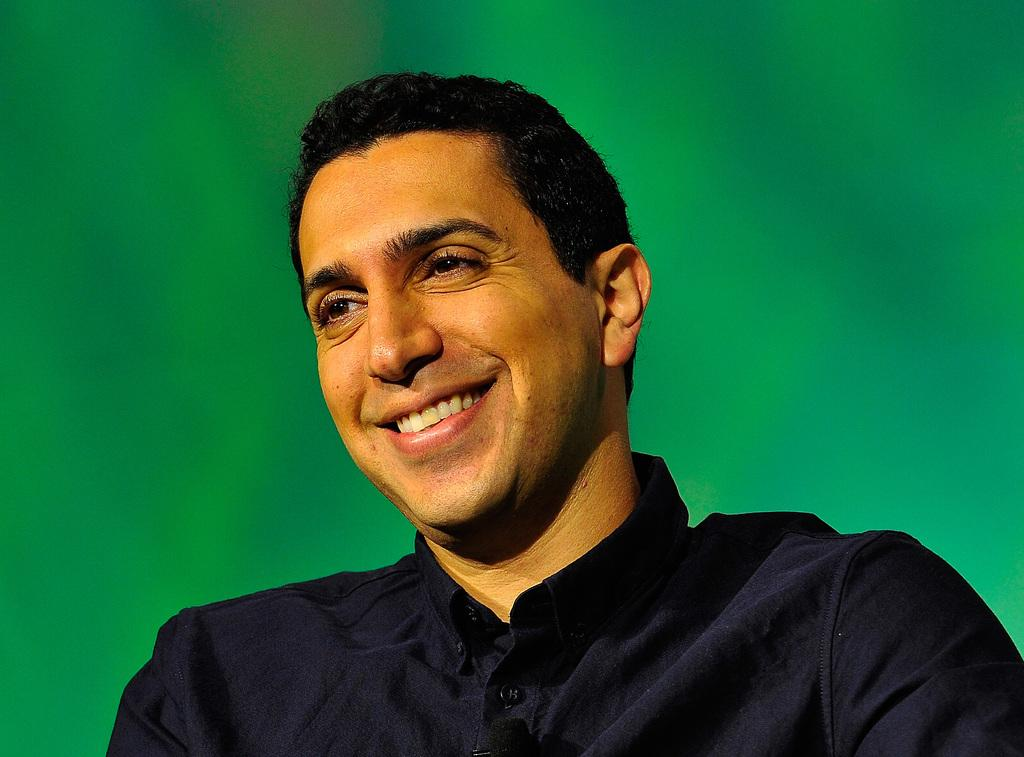What is present in the image? There is a man in the image. What is the man's facial expression in the image? The man is smiling in the image. What color does the background of the image appear to be? The background of the image appears green in color. What type of camera is the man holding in the image? There is no camera visible in the image; the man is not holding any object. How many people are present in the image? There is only one person present in the image, which is the man. 